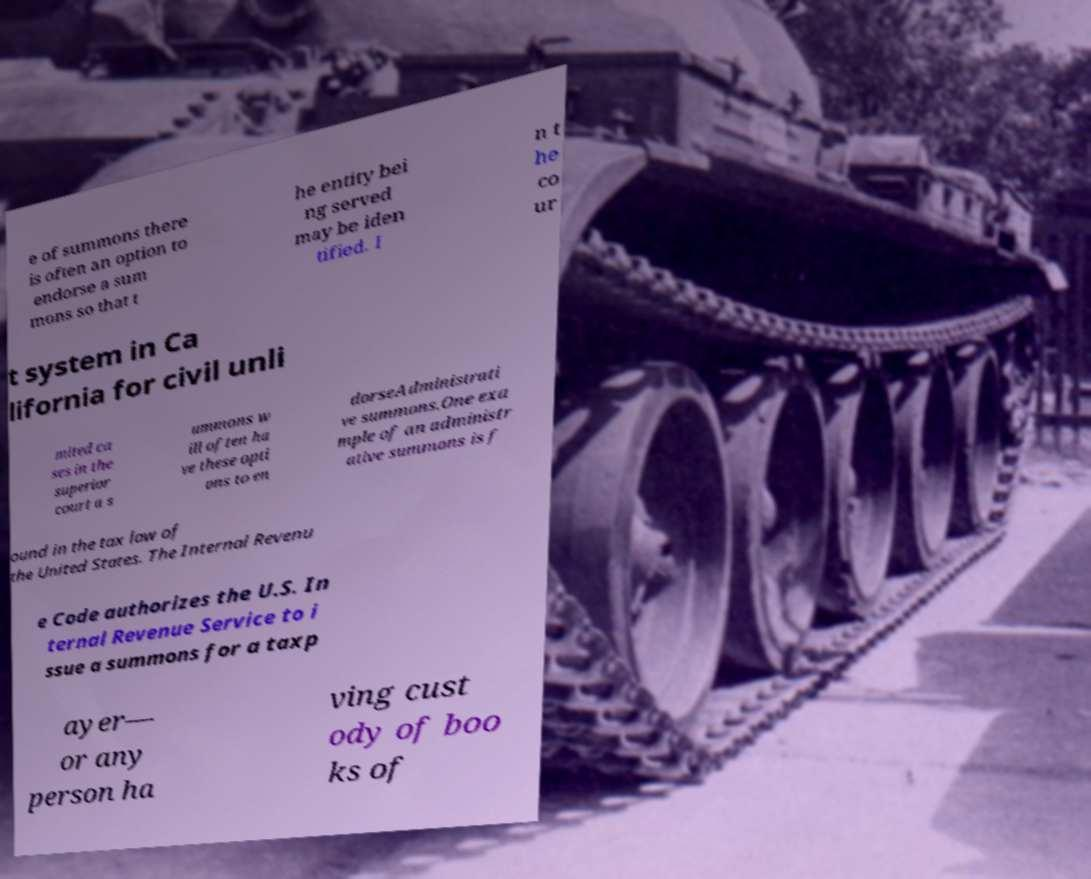There's text embedded in this image that I need extracted. Can you transcribe it verbatim? e of summons there is often an option to endorse a sum mons so that t he entity bei ng served may be iden tified. I n t he co ur t system in Ca lifornia for civil unli mited ca ses in the superior court a s ummons w ill often ha ve these opti ons to en dorseAdministrati ve summons.One exa mple of an administr ative summons is f ound in the tax law of the United States. The Internal Revenu e Code authorizes the U.S. In ternal Revenue Service to i ssue a summons for a taxp ayer— or any person ha ving cust ody of boo ks of 